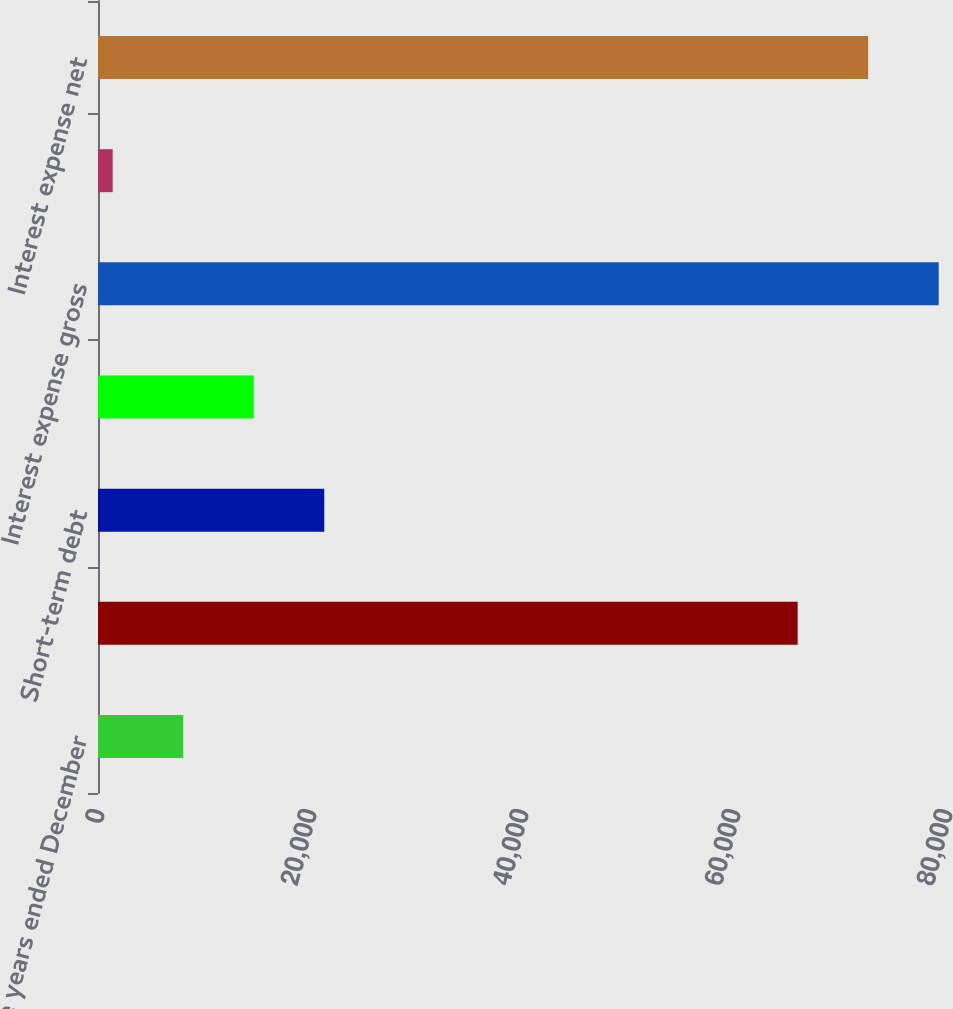<chart> <loc_0><loc_0><loc_500><loc_500><bar_chart><fcel>For the years ended December<fcel>Long-term debt and lease<fcel>Short-term debt<fcel>Capitalized interest<fcel>Interest expense gross<fcel>Interest income<fcel>Interest expense net<nl><fcel>8039.3<fcel>66005<fcel>21345.9<fcel>14692.6<fcel>79311.6<fcel>1386<fcel>72658.3<nl></chart> 